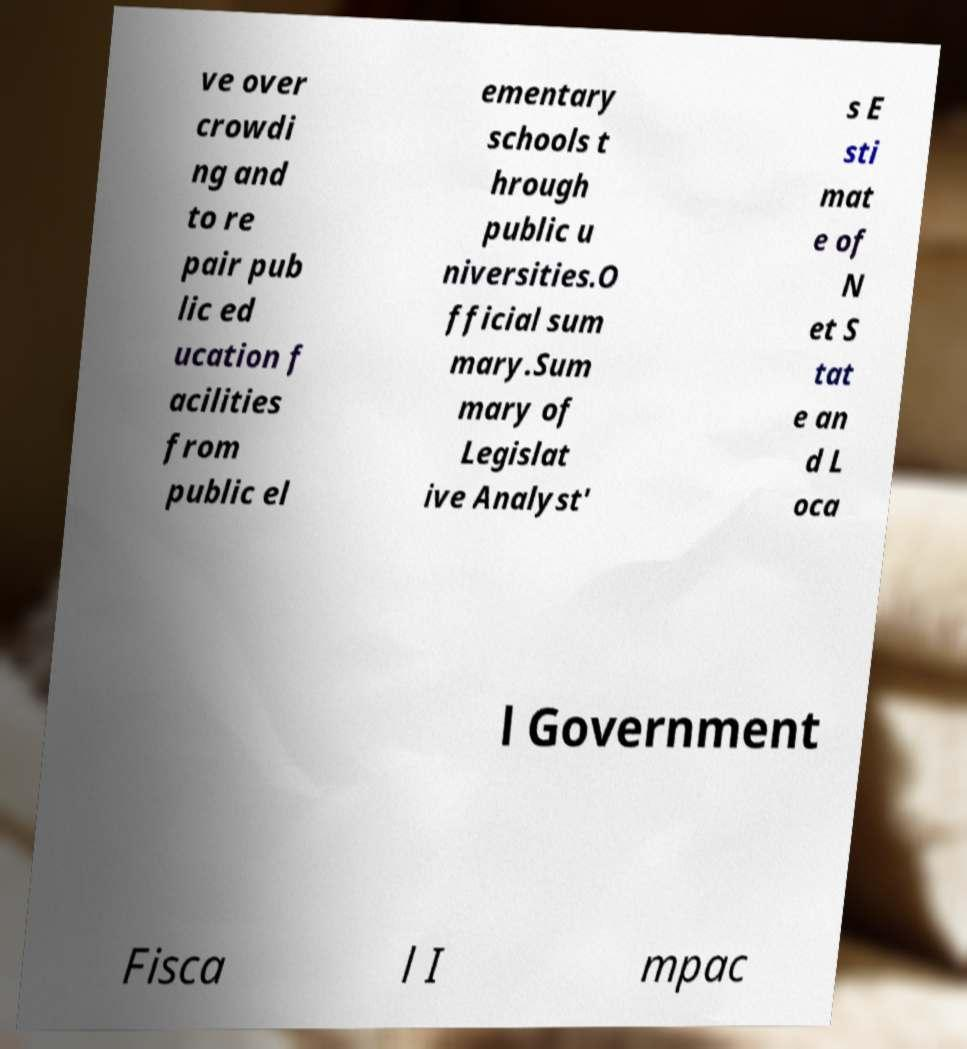Please identify and transcribe the text found in this image. ve over crowdi ng and to re pair pub lic ed ucation f acilities from public el ementary schools t hrough public u niversities.O fficial sum mary.Sum mary of Legislat ive Analyst' s E sti mat e of N et S tat e an d L oca l Government Fisca l I mpac 